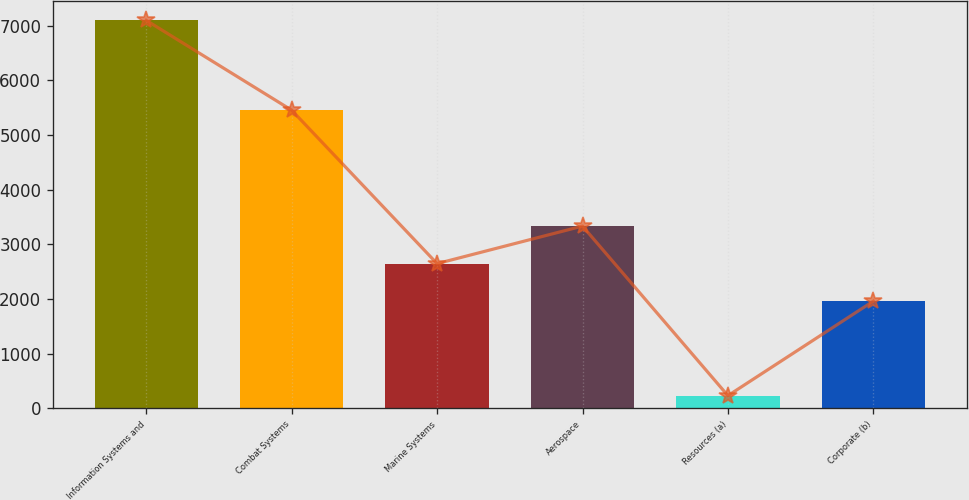Convert chart. <chart><loc_0><loc_0><loc_500><loc_500><bar_chart><fcel>Information Systems and<fcel>Combat Systems<fcel>Marine Systems<fcel>Aerospace<fcel>Resources (a)<fcel>Corporate (b)<nl><fcel>7095<fcel>5452<fcel>2644.6<fcel>3331.2<fcel>229<fcel>1958<nl></chart> 